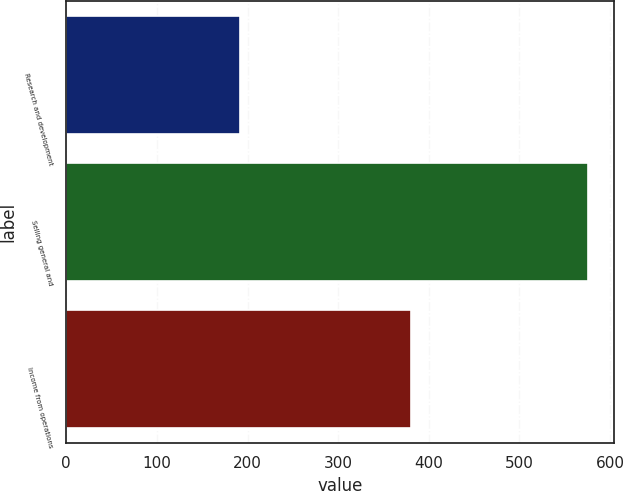<chart> <loc_0><loc_0><loc_500><loc_500><bar_chart><fcel>Research and development<fcel>Selling general and<fcel>Income from operations<nl><fcel>192<fcel>576<fcel>380<nl></chart> 